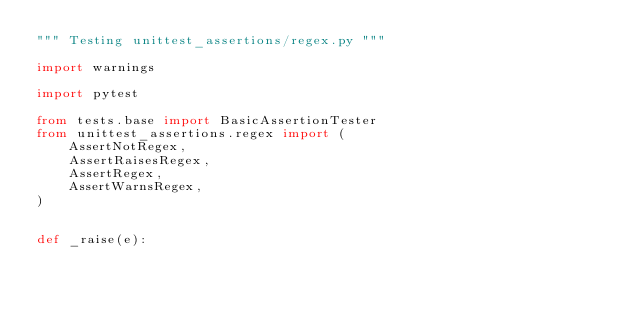<code> <loc_0><loc_0><loc_500><loc_500><_Python_>""" Testing unittest_assertions/regex.py """

import warnings

import pytest

from tests.base import BasicAssertionTester
from unittest_assertions.regex import (
    AssertNotRegex,
    AssertRaisesRegex,
    AssertRegex,
    AssertWarnsRegex,
)


def _raise(e):</code> 